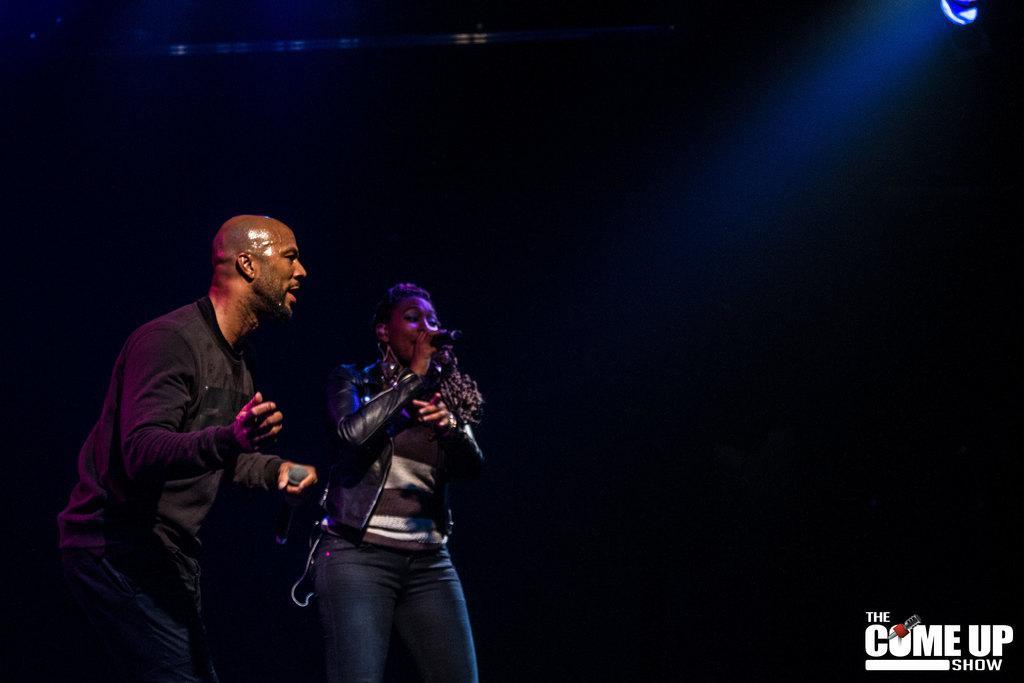Describe this image in one or two sentences. In this image, we can see people holding mics in their hands and at the top, we can see a light and the background is dark. At the bottom, there is some text written. 